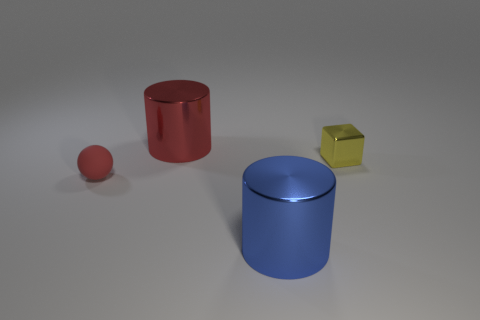There is a metal cylinder in front of the small block; is it the same size as the yellow thing right of the blue cylinder?
Offer a terse response. No. What number of yellow cubes have the same material as the small red object?
Offer a terse response. 0. What number of tiny yellow things are behind the cylinder in front of the shiny cylinder behind the blue shiny cylinder?
Provide a short and direct response. 1. Does the tiny red object have the same shape as the blue object?
Offer a very short reply. No. Is there a large gray matte thing that has the same shape as the small yellow object?
Ensure brevity in your answer.  No. What shape is the object that is the same size as the metal block?
Keep it short and to the point. Sphere. The cylinder that is behind the small object on the left side of the large metal thing behind the large blue object is made of what material?
Your response must be concise. Metal. Do the red sphere and the blue metallic cylinder have the same size?
Your response must be concise. No. What material is the red sphere?
Your answer should be compact. Rubber. What is the material of the other object that is the same color as the rubber thing?
Your answer should be compact. Metal. 